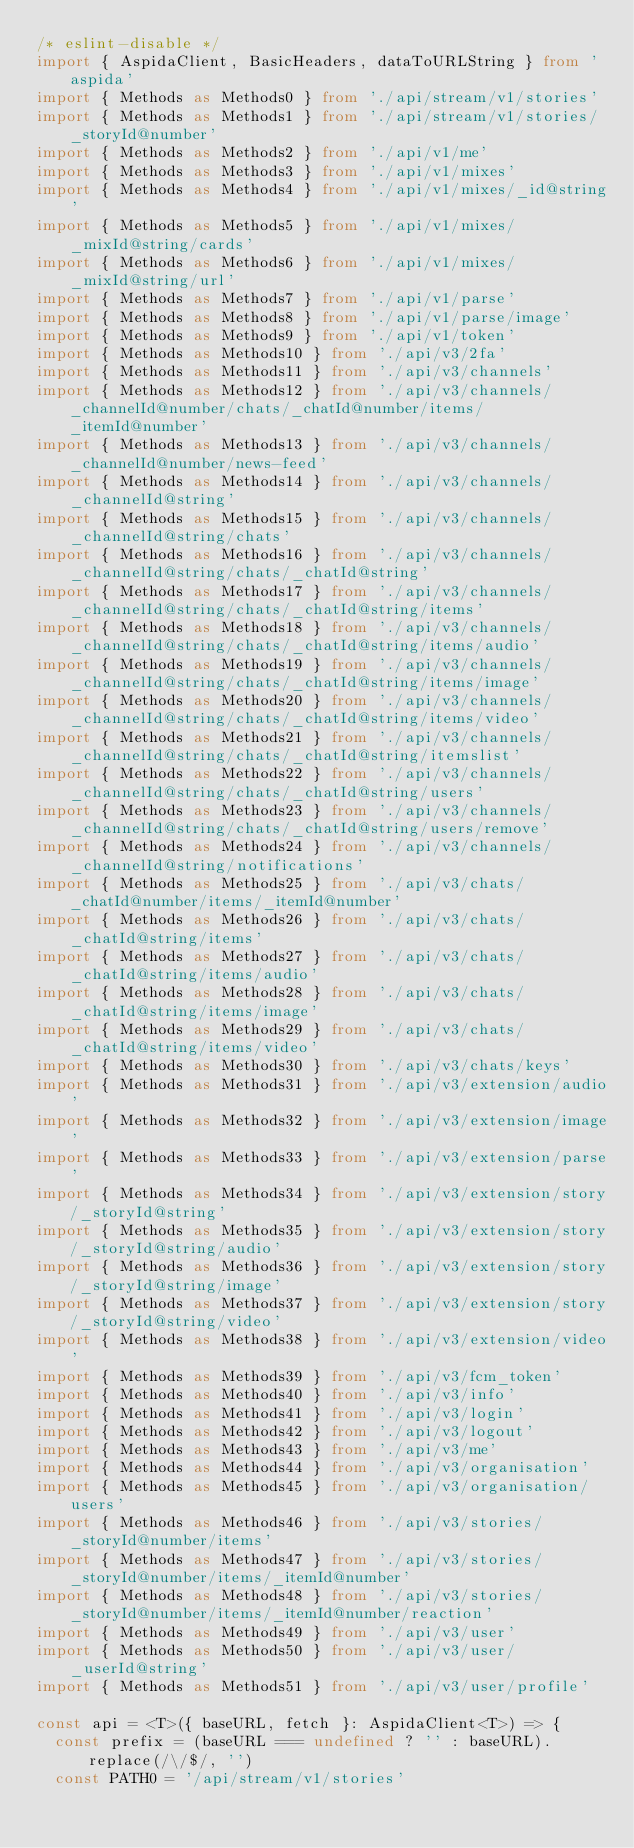<code> <loc_0><loc_0><loc_500><loc_500><_TypeScript_>/* eslint-disable */
import { AspidaClient, BasicHeaders, dataToURLString } from 'aspida'
import { Methods as Methods0 } from './api/stream/v1/stories'
import { Methods as Methods1 } from './api/stream/v1/stories/_storyId@number'
import { Methods as Methods2 } from './api/v1/me'
import { Methods as Methods3 } from './api/v1/mixes'
import { Methods as Methods4 } from './api/v1/mixes/_id@string'
import { Methods as Methods5 } from './api/v1/mixes/_mixId@string/cards'
import { Methods as Methods6 } from './api/v1/mixes/_mixId@string/url'
import { Methods as Methods7 } from './api/v1/parse'
import { Methods as Methods8 } from './api/v1/parse/image'
import { Methods as Methods9 } from './api/v1/token'
import { Methods as Methods10 } from './api/v3/2fa'
import { Methods as Methods11 } from './api/v3/channels'
import { Methods as Methods12 } from './api/v3/channels/_channelId@number/chats/_chatId@number/items/_itemId@number'
import { Methods as Methods13 } from './api/v3/channels/_channelId@number/news-feed'
import { Methods as Methods14 } from './api/v3/channels/_channelId@string'
import { Methods as Methods15 } from './api/v3/channels/_channelId@string/chats'
import { Methods as Methods16 } from './api/v3/channels/_channelId@string/chats/_chatId@string'
import { Methods as Methods17 } from './api/v3/channels/_channelId@string/chats/_chatId@string/items'
import { Methods as Methods18 } from './api/v3/channels/_channelId@string/chats/_chatId@string/items/audio'
import { Methods as Methods19 } from './api/v3/channels/_channelId@string/chats/_chatId@string/items/image'
import { Methods as Methods20 } from './api/v3/channels/_channelId@string/chats/_chatId@string/items/video'
import { Methods as Methods21 } from './api/v3/channels/_channelId@string/chats/_chatId@string/itemslist'
import { Methods as Methods22 } from './api/v3/channels/_channelId@string/chats/_chatId@string/users'
import { Methods as Methods23 } from './api/v3/channels/_channelId@string/chats/_chatId@string/users/remove'
import { Methods as Methods24 } from './api/v3/channels/_channelId@string/notifications'
import { Methods as Methods25 } from './api/v3/chats/_chatId@number/items/_itemId@number'
import { Methods as Methods26 } from './api/v3/chats/_chatId@string/items'
import { Methods as Methods27 } from './api/v3/chats/_chatId@string/items/audio'
import { Methods as Methods28 } from './api/v3/chats/_chatId@string/items/image'
import { Methods as Methods29 } from './api/v3/chats/_chatId@string/items/video'
import { Methods as Methods30 } from './api/v3/chats/keys'
import { Methods as Methods31 } from './api/v3/extension/audio'
import { Methods as Methods32 } from './api/v3/extension/image'
import { Methods as Methods33 } from './api/v3/extension/parse'
import { Methods as Methods34 } from './api/v3/extension/story/_storyId@string'
import { Methods as Methods35 } from './api/v3/extension/story/_storyId@string/audio'
import { Methods as Methods36 } from './api/v3/extension/story/_storyId@string/image'
import { Methods as Methods37 } from './api/v3/extension/story/_storyId@string/video'
import { Methods as Methods38 } from './api/v3/extension/video'
import { Methods as Methods39 } from './api/v3/fcm_token'
import { Methods as Methods40 } from './api/v3/info'
import { Methods as Methods41 } from './api/v3/login'
import { Methods as Methods42 } from './api/v3/logout'
import { Methods as Methods43 } from './api/v3/me'
import { Methods as Methods44 } from './api/v3/organisation'
import { Methods as Methods45 } from './api/v3/organisation/users'
import { Methods as Methods46 } from './api/v3/stories/_storyId@number/items'
import { Methods as Methods47 } from './api/v3/stories/_storyId@number/items/_itemId@number'
import { Methods as Methods48 } from './api/v3/stories/_storyId@number/items/_itemId@number/reaction'
import { Methods as Methods49 } from './api/v3/user'
import { Methods as Methods50 } from './api/v3/user/_userId@string'
import { Methods as Methods51 } from './api/v3/user/profile'

const api = <T>({ baseURL, fetch }: AspidaClient<T>) => {
  const prefix = (baseURL === undefined ? '' : baseURL).replace(/\/$/, '')
  const PATH0 = '/api/stream/v1/stories'</code> 